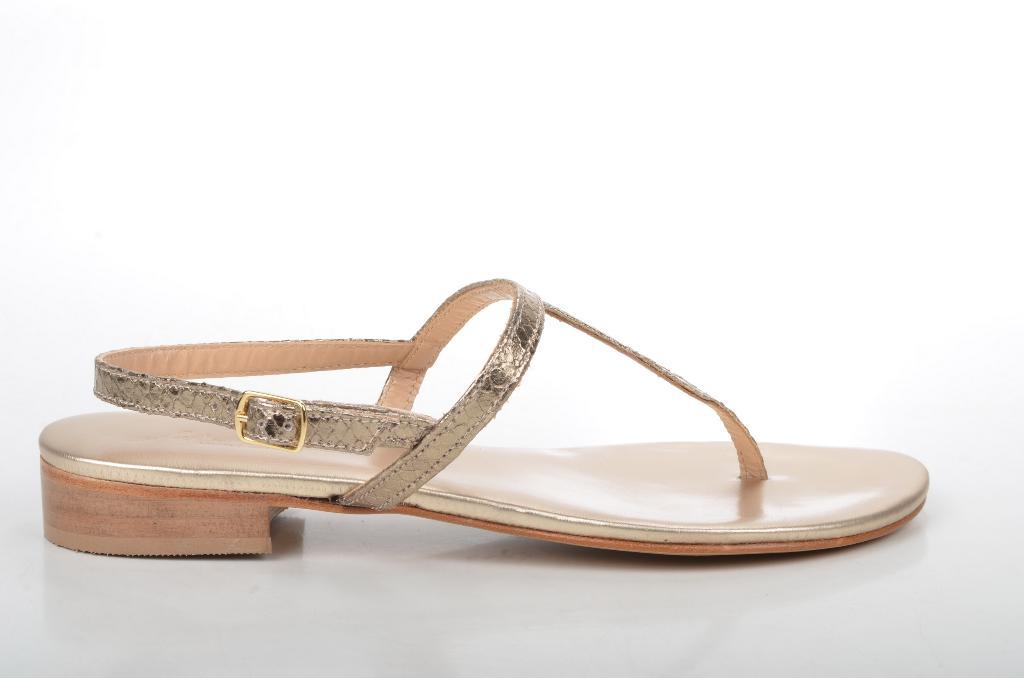What type of footwear is present in the image? There is a sandal in the image. Where is the sandal located? The sandal is placed on a platform. Is there a river flowing near the sandal in the image? There is no river present in the image; it only features a sandal placed on a platform. 